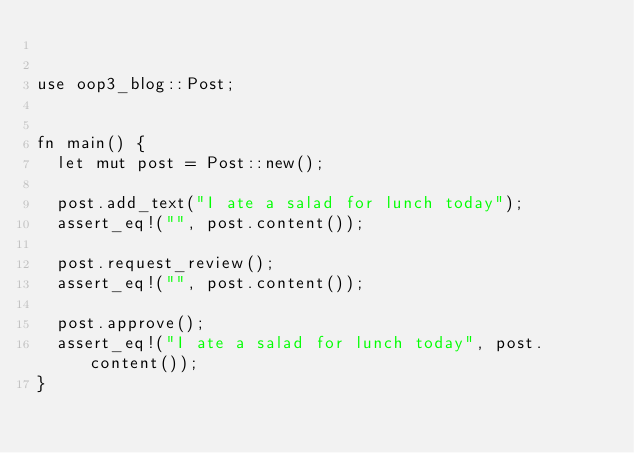Convert code to text. <code><loc_0><loc_0><loc_500><loc_500><_Rust_>

use oop3_blog::Post;


fn main() {
	let mut post = Post::new();

	post.add_text("I ate a salad for lunch today");
	assert_eq!("", post.content());

	post.request_review();
	assert_eq!("", post.content());

	post.approve();
	assert_eq!("I ate a salad for lunch today", post.content());
}

</code> 